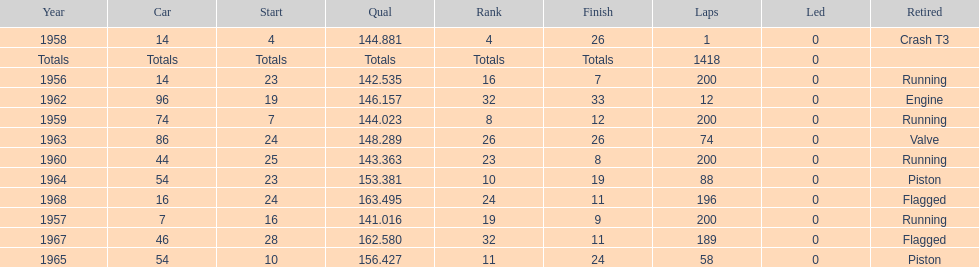How often did he successfully finish all 200 laps? 4. 